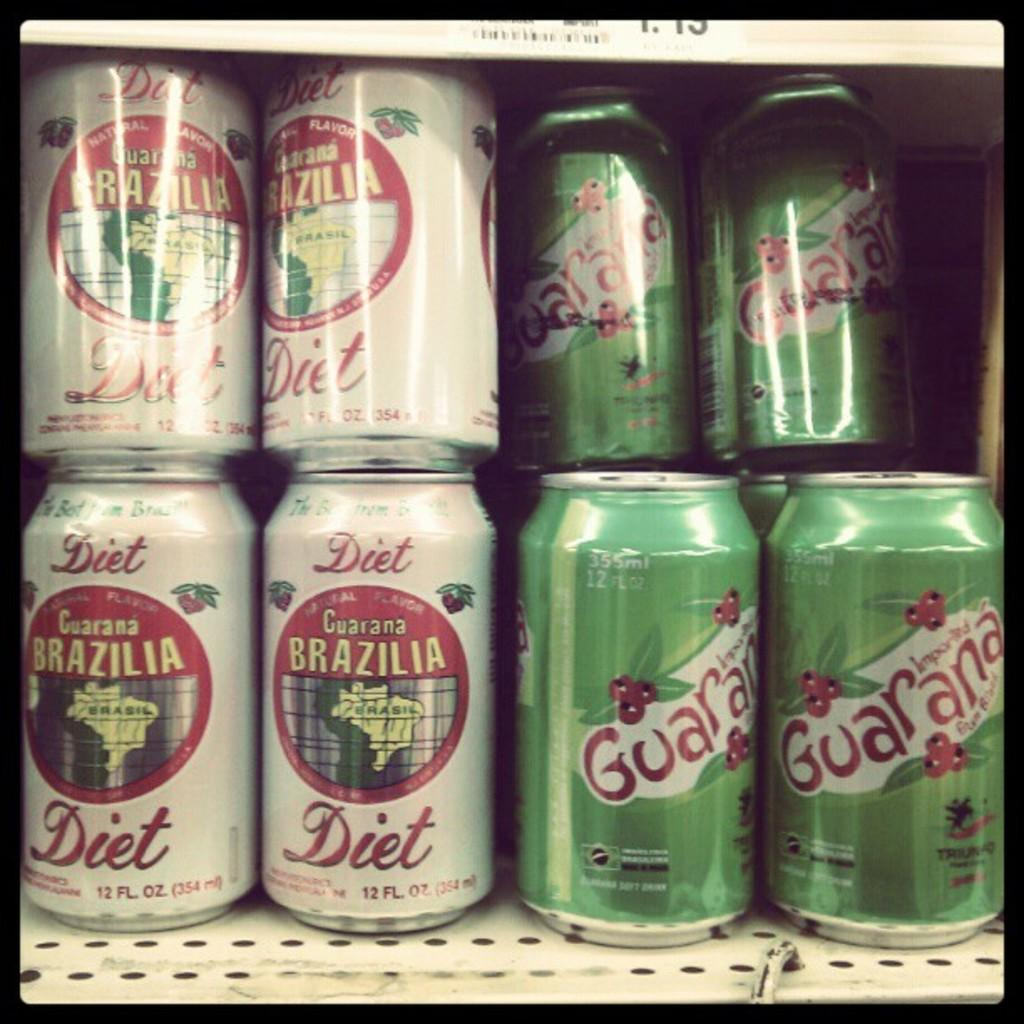<image>
Provide a brief description of the given image. Brazilia Guarana is sold in both Diet and regular flavors. 